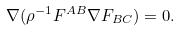<formula> <loc_0><loc_0><loc_500><loc_500>\nabla ( \rho ^ { - 1 } F ^ { A B } \nabla F _ { B C } ) = 0 .</formula> 